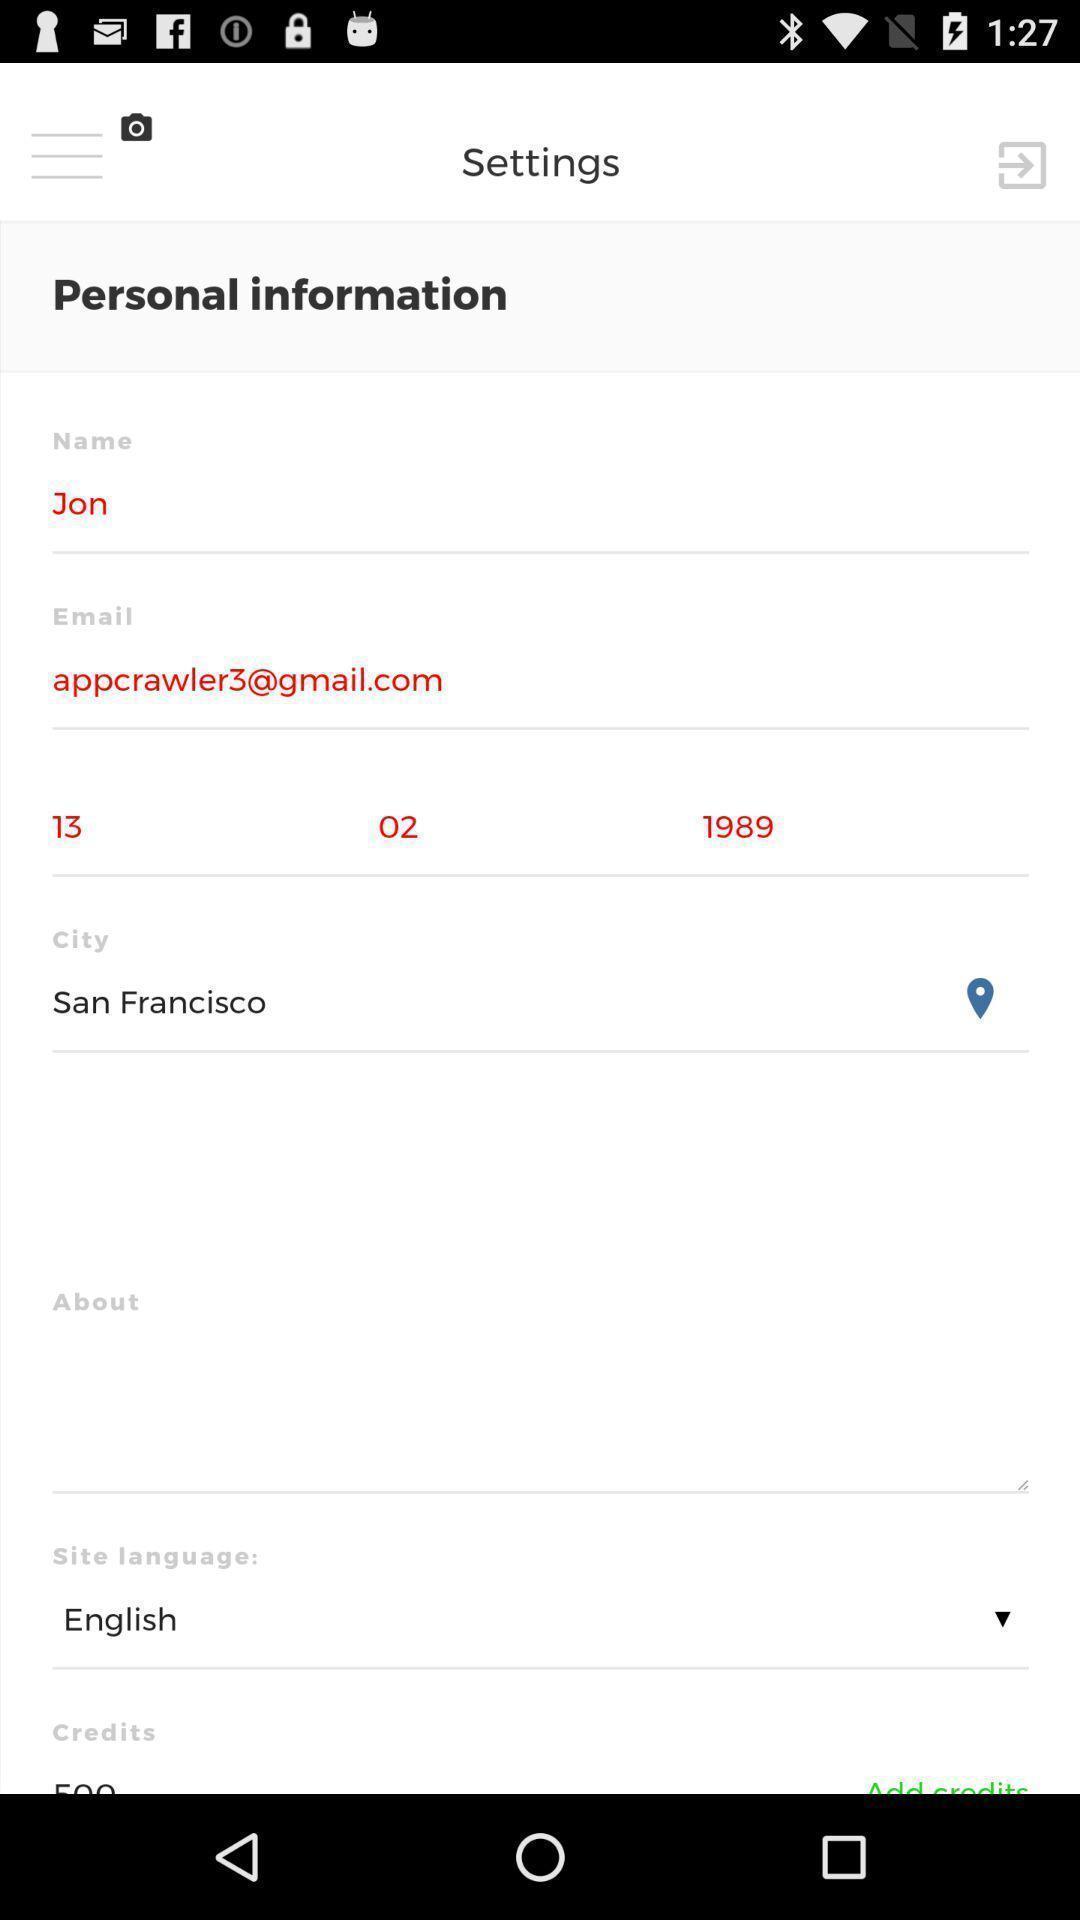What is the overall content of this screenshot? Setting page displaying the various options. 